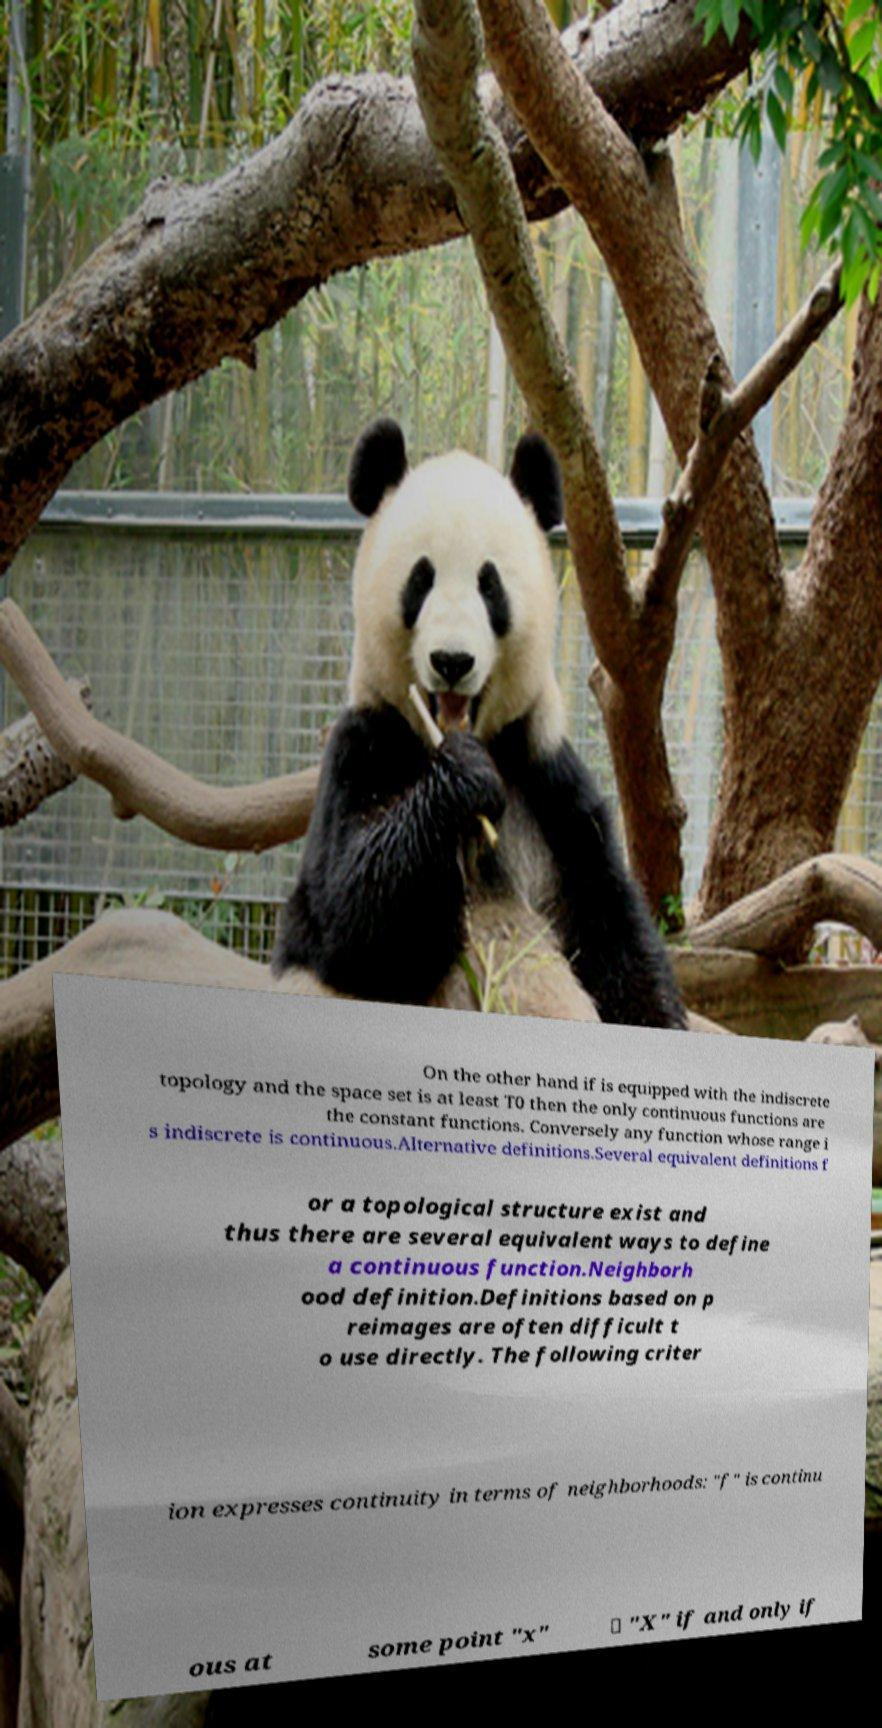Could you assist in decoding the text presented in this image and type it out clearly? On the other hand if is equipped with the indiscrete topology and the space set is at least T0 then the only continuous functions are the constant functions. Conversely any function whose range i s indiscrete is continuous.Alternative definitions.Several equivalent definitions f or a topological structure exist and thus there are several equivalent ways to define a continuous function.Neighborh ood definition.Definitions based on p reimages are often difficult t o use directly. The following criter ion expresses continuity in terms of neighborhoods: "f" is continu ous at some point "x" ∈ "X" if and only if 